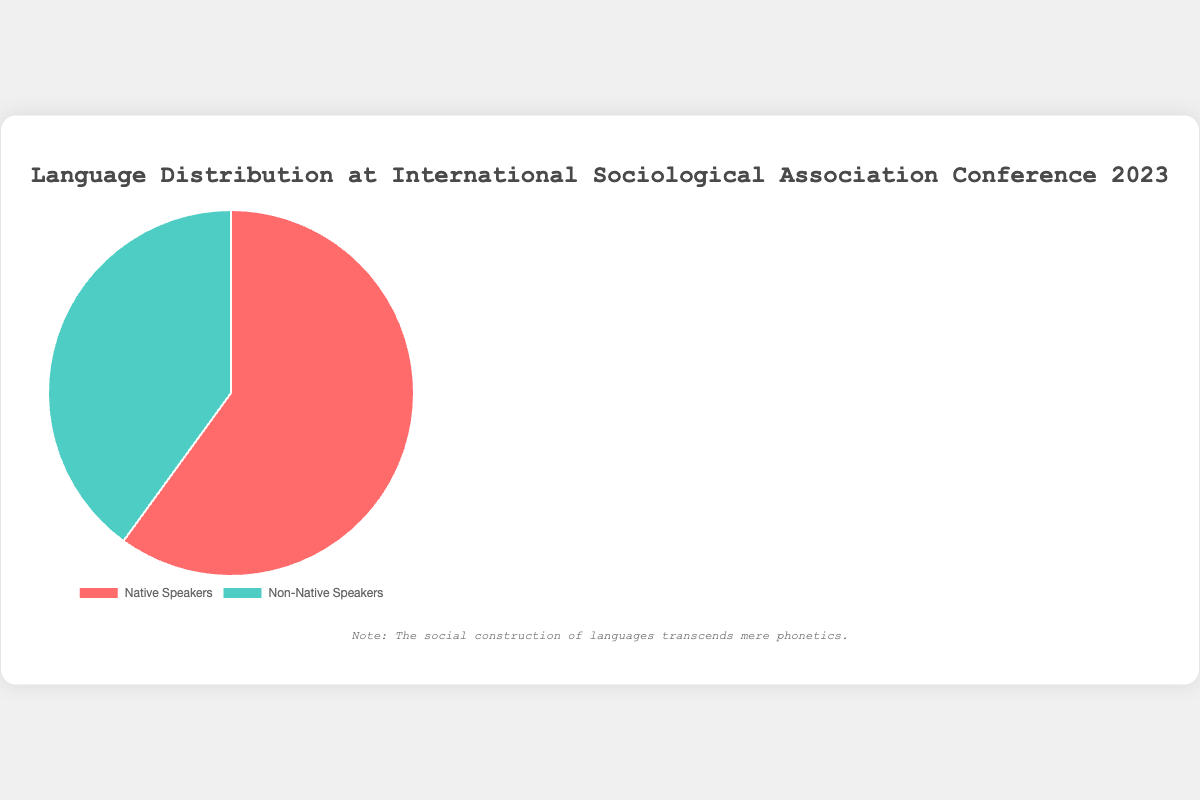What percentage of attendees are native speakers? This is a direct lookup. Based on the figure, the percentage of native speakers is labeled as 60%.
Answer: 60% What percentage of attendees are non-native speakers? This is a direct lookup. Based on the figure, the percentage of non-native speakers is labeled as 40%.
Answer: 40% Are there more native speakers or non-native speakers at the conference? This is a comparison. The figure shows native speakers at 60% and non-native speakers at 40%, indicating that native speakers are more than non-native speakers.
Answer: Native speakers How much greater is the percentage of native speakers compared to non-native speakers? This involves subtraction. The percentage of native speakers (60%) minus the percentage of non-native speakers (40%) equals 20%.
Answer: 20% If the total number of attendees is 1000, how many are native speakers? This involves multiplication. You multiply the total number of attendees (1000) by the percentage of native speakers (60%), resulting in 600 native speakers.
Answer: 600 If there are 600 native speakers, how many total attendees are there at the conference? This involves division. Given 600 native speakers account for 60%, we calculate the total by dividing 600 by 0.60, which equals 1000 attendees.
Answer: 1000 What would be the share of non-native speakers if the percentage of native speakers increased to 70%? This requires adjustment and subtraction. If native speakers increase to 70%, the share of non-native speakers would be 100% - 70% = 30%.
Answer: 30% What color represents the non-native speakers in the pie chart? This is a visual question. The figure shows non-native speakers in green.
Answer: Green 